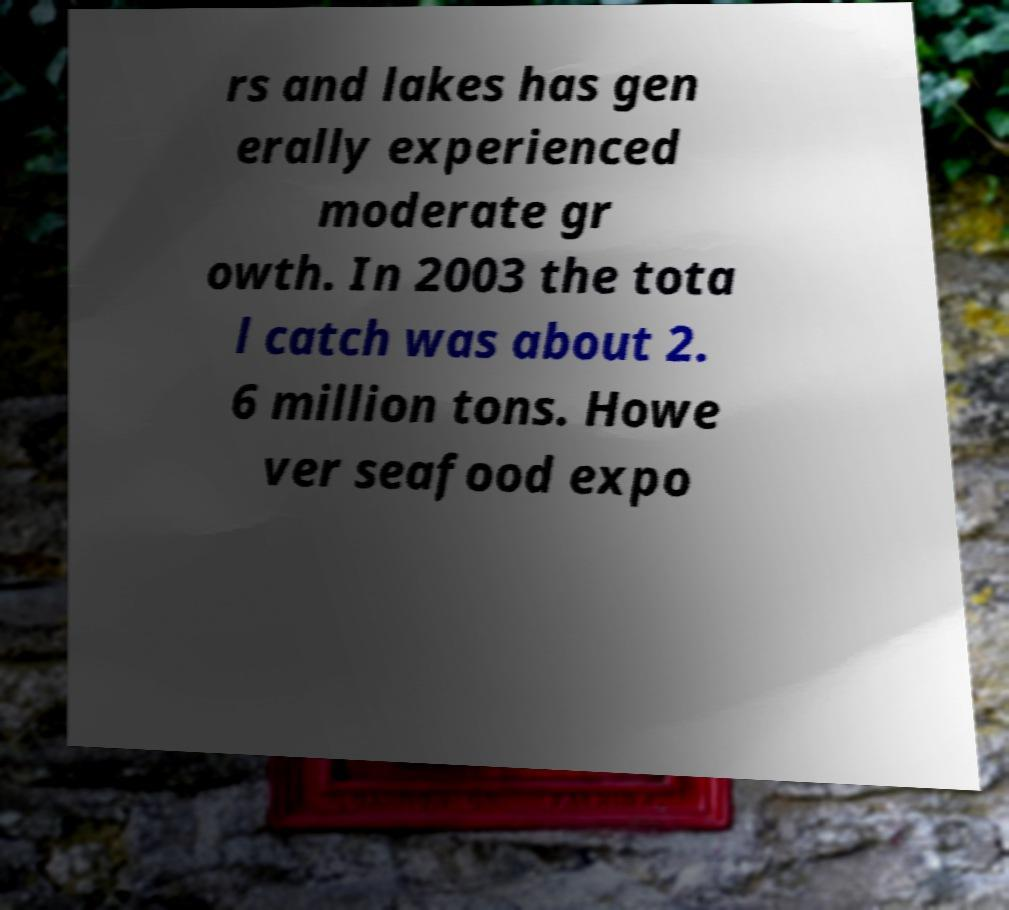I need the written content from this picture converted into text. Can you do that? rs and lakes has gen erally experienced moderate gr owth. In 2003 the tota l catch was about 2. 6 million tons. Howe ver seafood expo 